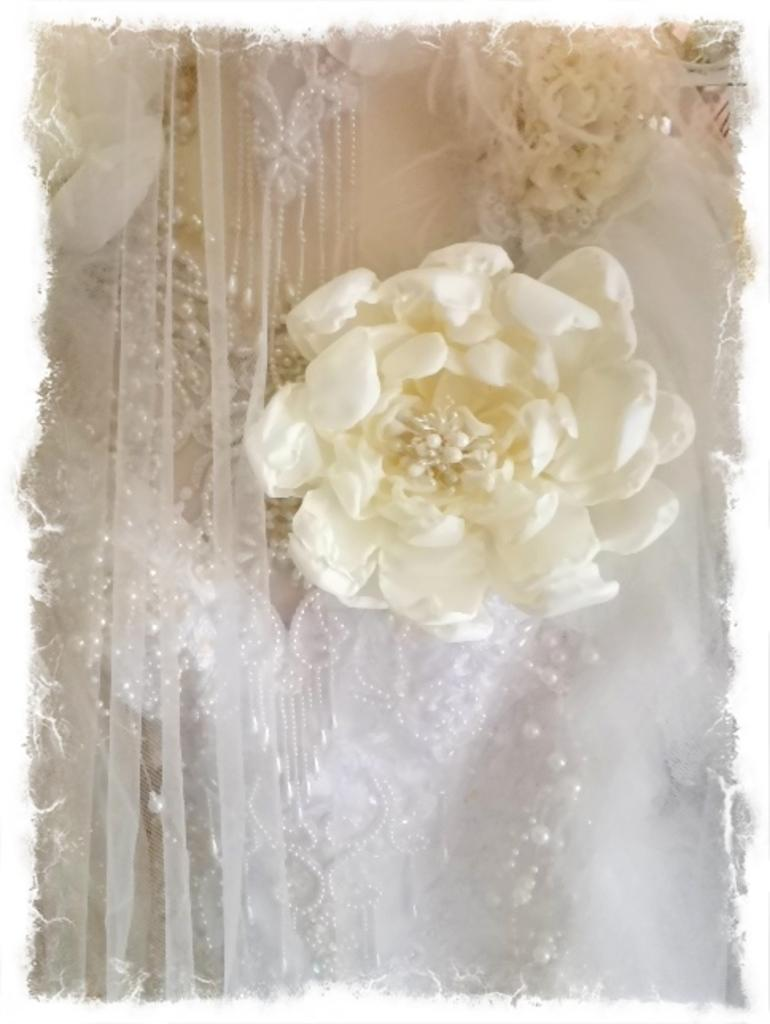What type of flower is visible on the dress in the image? There is a white color flower on the dress in the image. What is the flower placed on in the image? The flower is on a dress. Are there any other objects or decorations on the dress? Yes, there are other objects on the dress. What type of glass can be seen on the board in the image? There is no glass or board present in the image; it features a white color flower on a dress with other objects. 